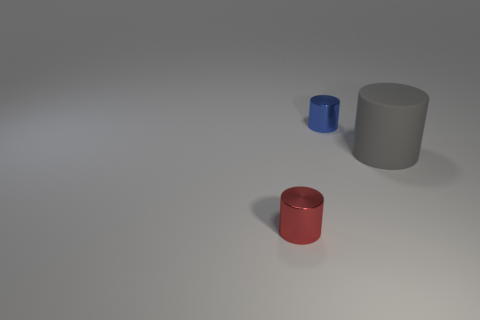Add 2 small blue metallic spheres. How many objects exist? 5 Add 1 large blue spheres. How many large blue spheres exist? 1 Subtract 0 blue cubes. How many objects are left? 3 Subtract all red metallic things. Subtract all tiny red shiny objects. How many objects are left? 1 Add 2 large gray matte things. How many large gray matte things are left? 3 